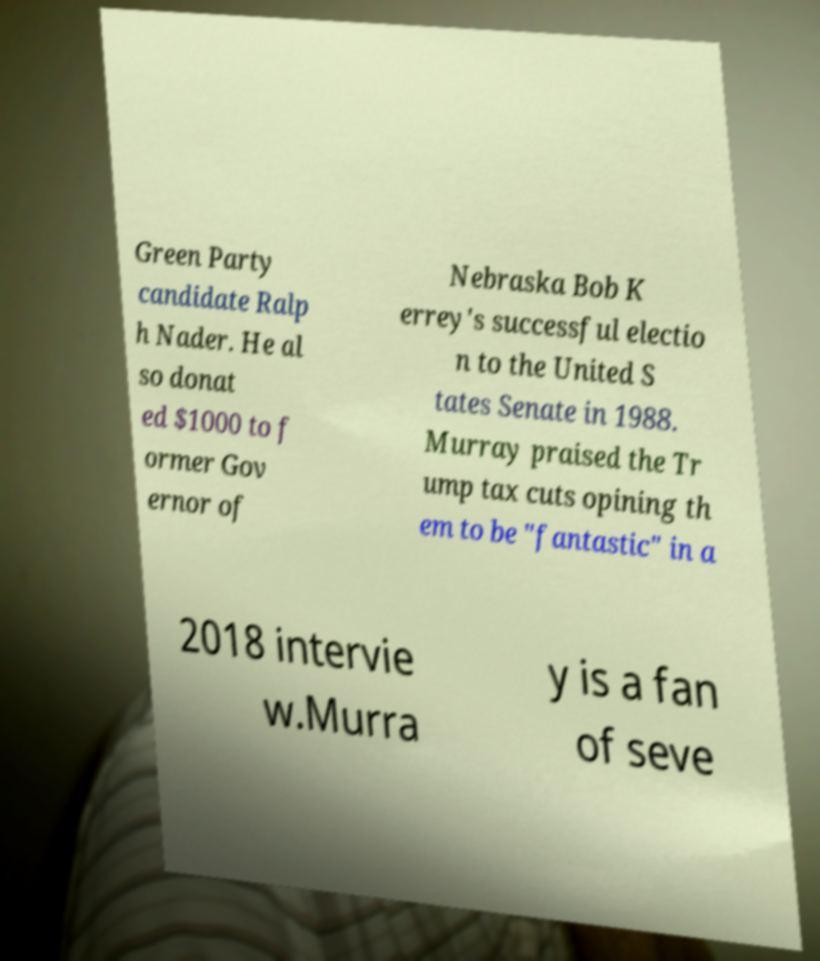Could you assist in decoding the text presented in this image and type it out clearly? Green Party candidate Ralp h Nader. He al so donat ed $1000 to f ormer Gov ernor of Nebraska Bob K errey's successful electio n to the United S tates Senate in 1988. Murray praised the Tr ump tax cuts opining th em to be "fantastic" in a 2018 intervie w.Murra y is a fan of seve 